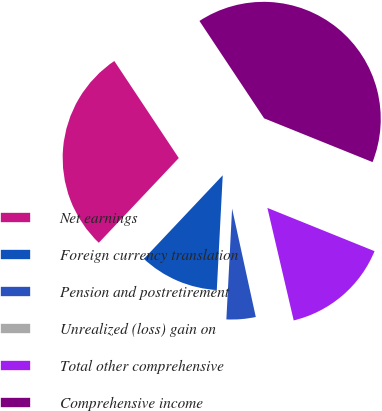<chart> <loc_0><loc_0><loc_500><loc_500><pie_chart><fcel>Net earnings<fcel>Foreign currency translation<fcel>Pension and postretirement<fcel>Unrealized (loss) gain on<fcel>Total other comprehensive<fcel>Comprehensive income<nl><fcel>28.63%<fcel>11.22%<fcel>4.25%<fcel>0.23%<fcel>15.24%<fcel>40.44%<nl></chart> 